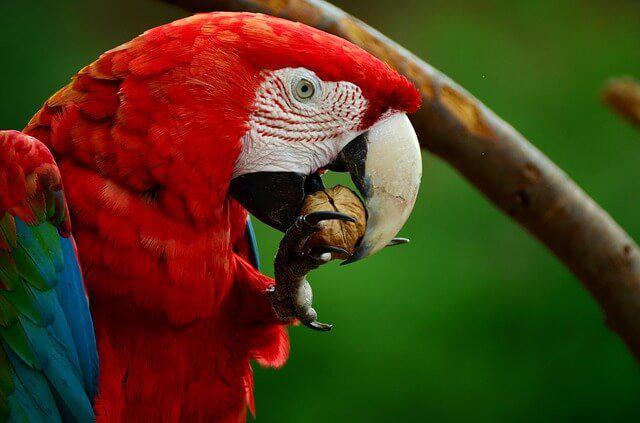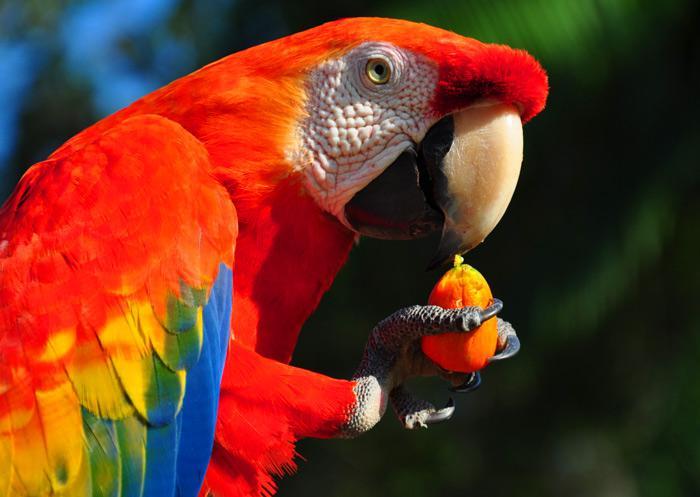The first image is the image on the left, the second image is the image on the right. Given the left and right images, does the statement "At least one image shows a red-headed parrot lifting a kind of nut with one claw towards its beak." hold true? Answer yes or no. Yes. The first image is the image on the left, the second image is the image on the right. Examine the images to the left and right. Is the description "A parrot is eating something in at least one of the images." accurate? Answer yes or no. Yes. 